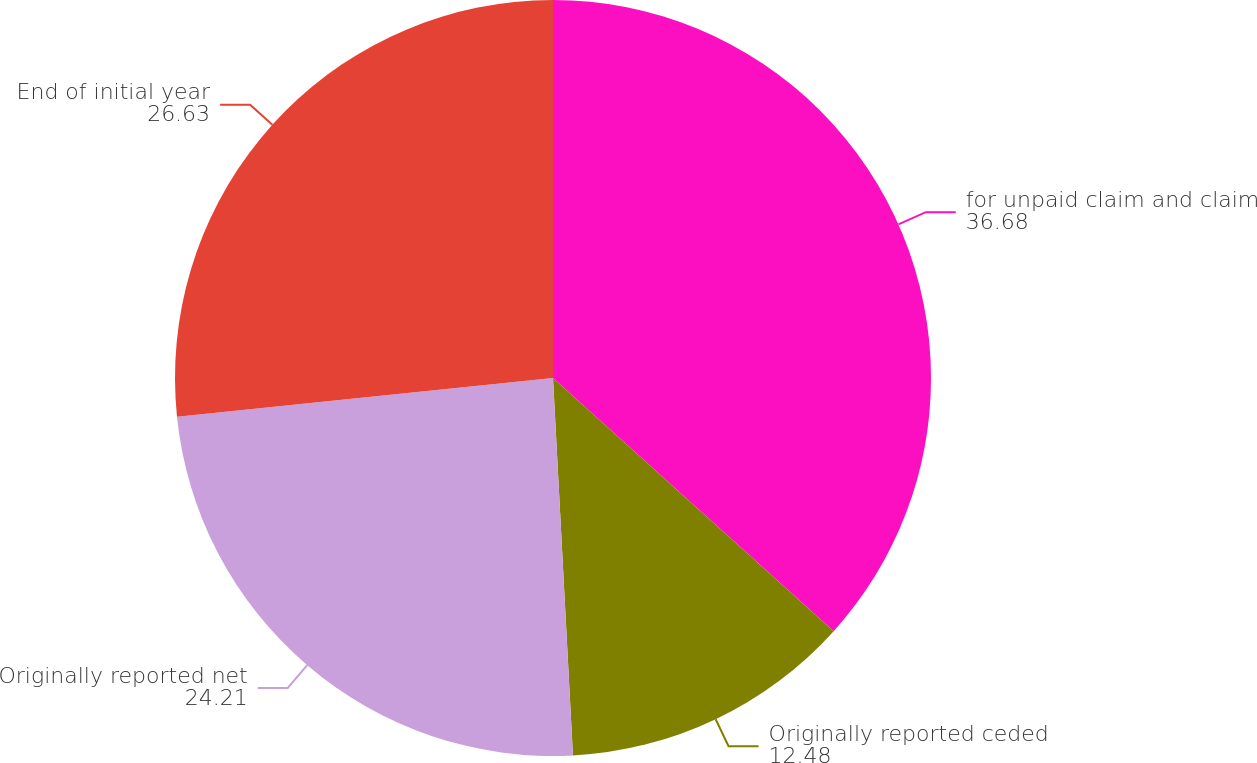<chart> <loc_0><loc_0><loc_500><loc_500><pie_chart><fcel>for unpaid claim and claim<fcel>Originally reported ceded<fcel>Originally reported net<fcel>End of initial year<nl><fcel>36.68%<fcel>12.48%<fcel>24.21%<fcel>26.63%<nl></chart> 